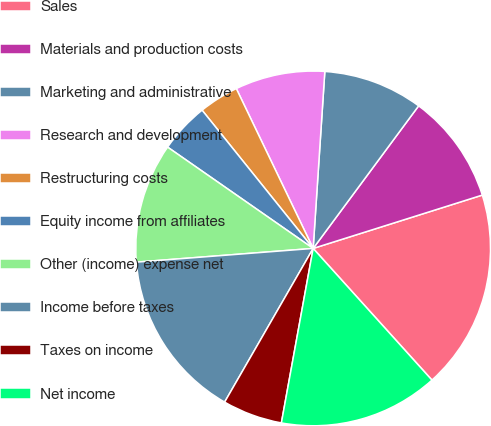Convert chart to OTSL. <chart><loc_0><loc_0><loc_500><loc_500><pie_chart><fcel>Sales<fcel>Materials and production costs<fcel>Marketing and administrative<fcel>Research and development<fcel>Restructuring costs<fcel>Equity income from affiliates<fcel>Other (income) expense net<fcel>Income before taxes<fcel>Taxes on income<fcel>Net income<nl><fcel>18.18%<fcel>10.0%<fcel>9.09%<fcel>8.18%<fcel>3.64%<fcel>4.55%<fcel>10.91%<fcel>15.45%<fcel>5.45%<fcel>14.55%<nl></chart> 